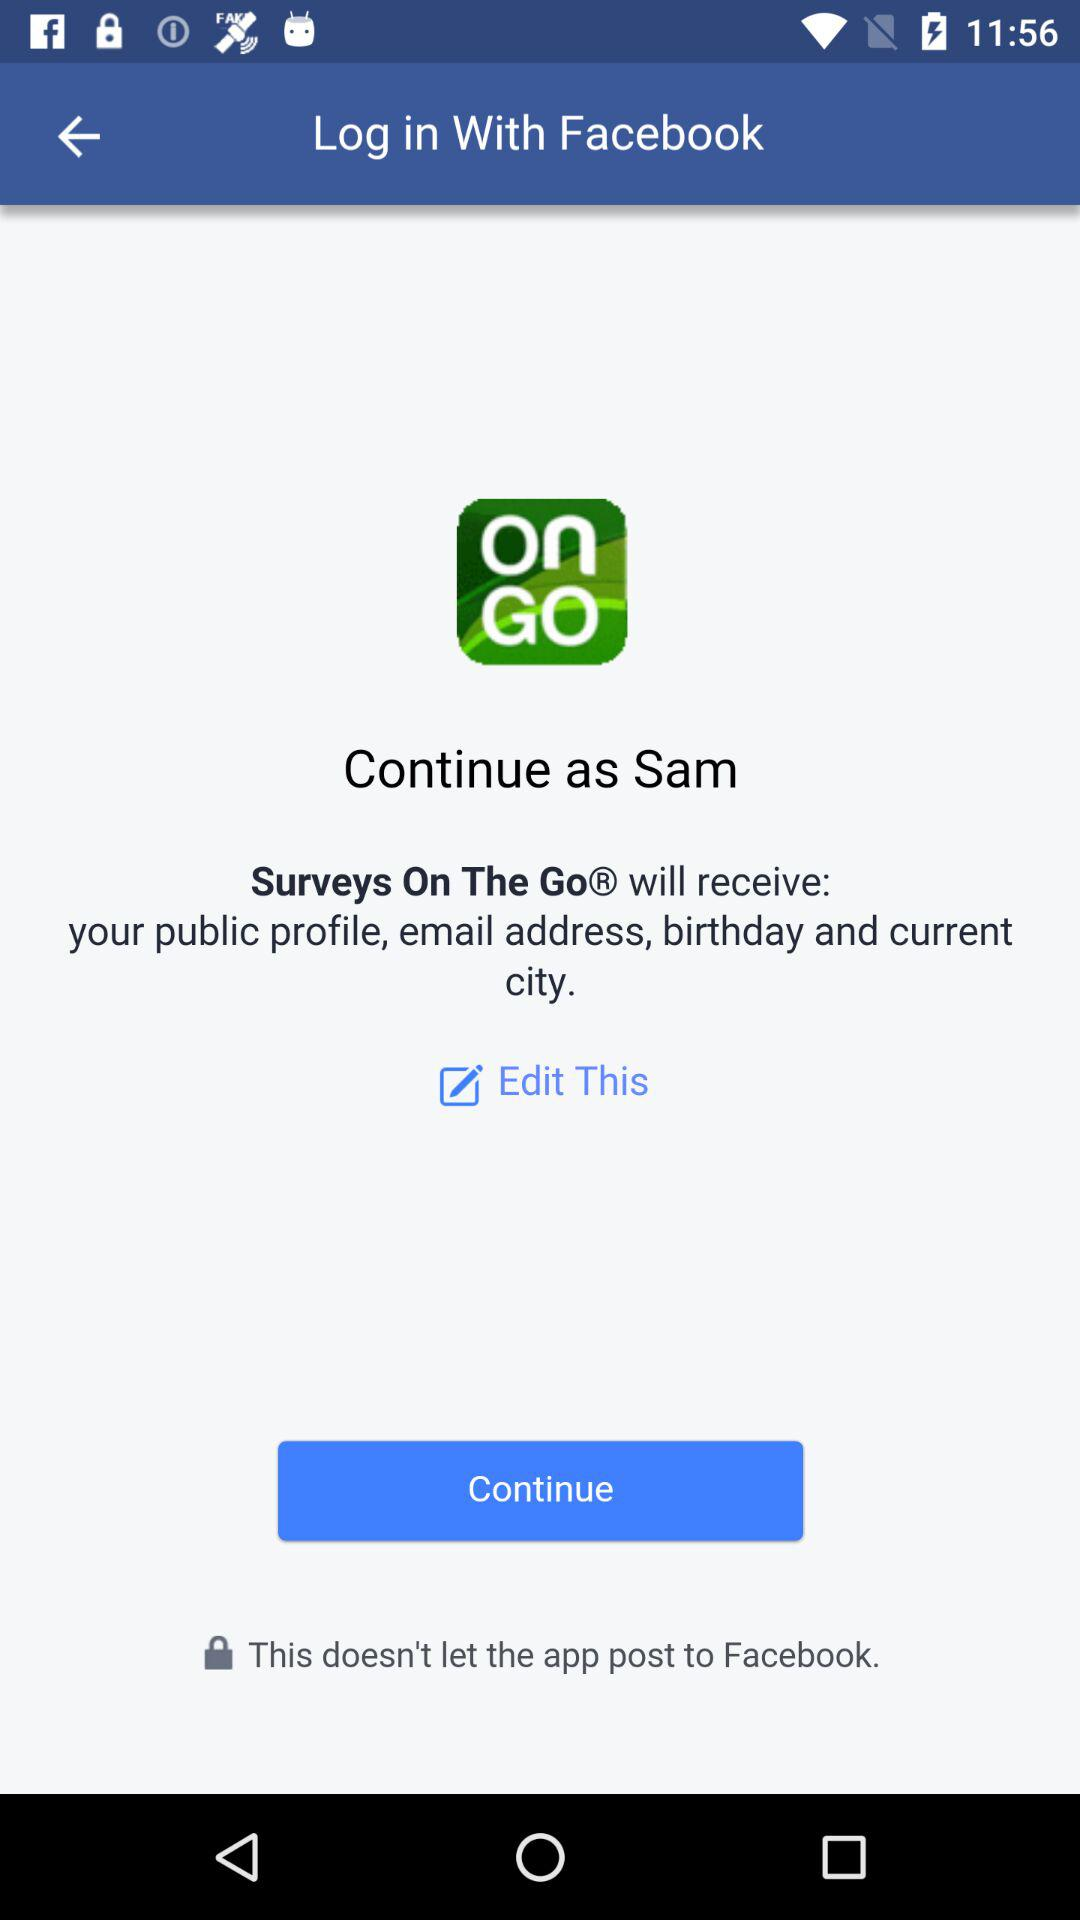What app will receive your public profile? The app that will receive your public profile is "Surveys On The Go". 